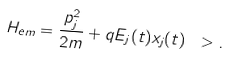Convert formula to latex. <formula><loc_0><loc_0><loc_500><loc_500>H _ { e m } = \frac { p _ { j } ^ { 2 } } { 2 m } + q E _ { j } ( t ) x _ { j } ( t ) \ > .</formula> 